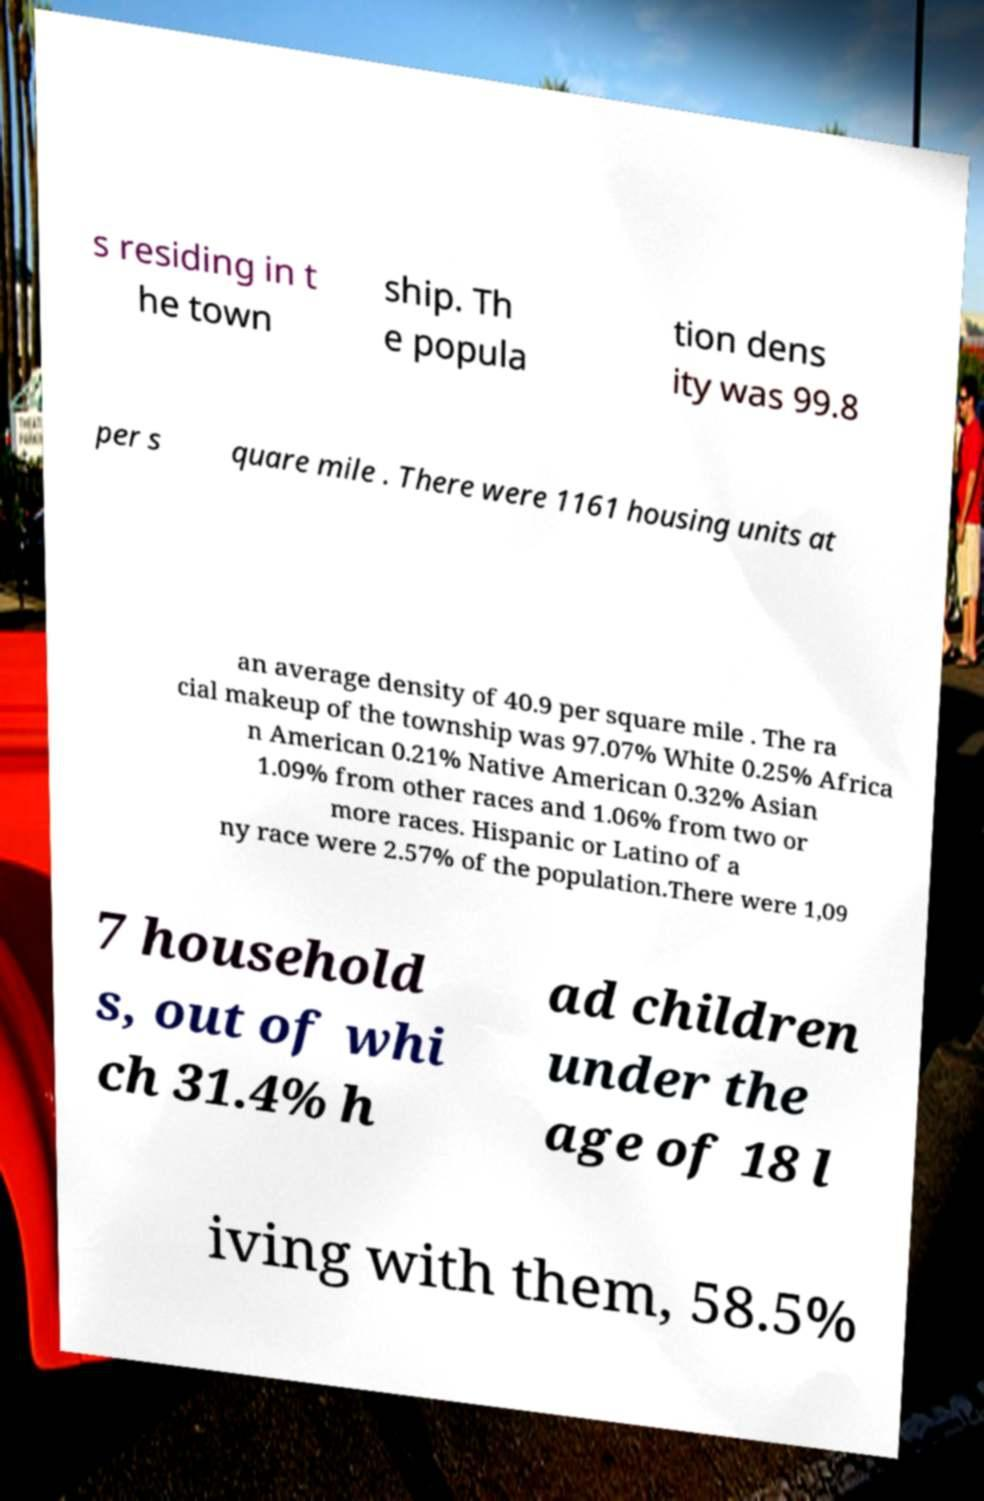Please read and relay the text visible in this image. What does it say? s residing in t he town ship. Th e popula tion dens ity was 99.8 per s quare mile . There were 1161 housing units at an average density of 40.9 per square mile . The ra cial makeup of the township was 97.07% White 0.25% Africa n American 0.21% Native American 0.32% Asian 1.09% from other races and 1.06% from two or more races. Hispanic or Latino of a ny race were 2.57% of the population.There were 1,09 7 household s, out of whi ch 31.4% h ad children under the age of 18 l iving with them, 58.5% 